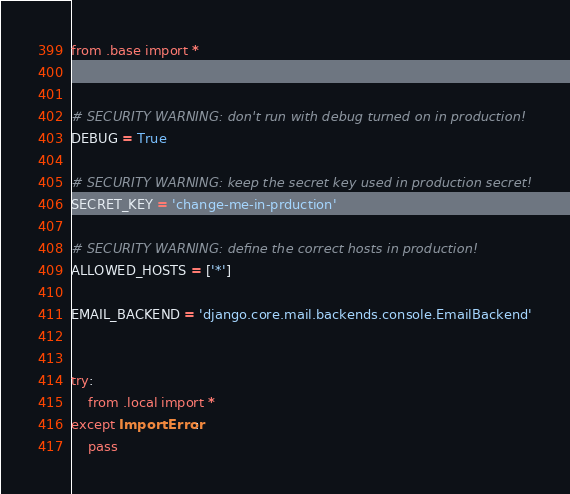<code> <loc_0><loc_0><loc_500><loc_500><_Python_>from .base import *


# SECURITY WARNING: don't run with debug turned on in production!
DEBUG = True

# SECURITY WARNING: keep the secret key used in production secret!
SECRET_KEY = 'change-me-in-prduction'

# SECURITY WARNING: define the correct hosts in production!
ALLOWED_HOSTS = ['*'] 

EMAIL_BACKEND = 'django.core.mail.backends.console.EmailBackend'


try:
    from .local import *
except ImportError:
    pass
</code> 